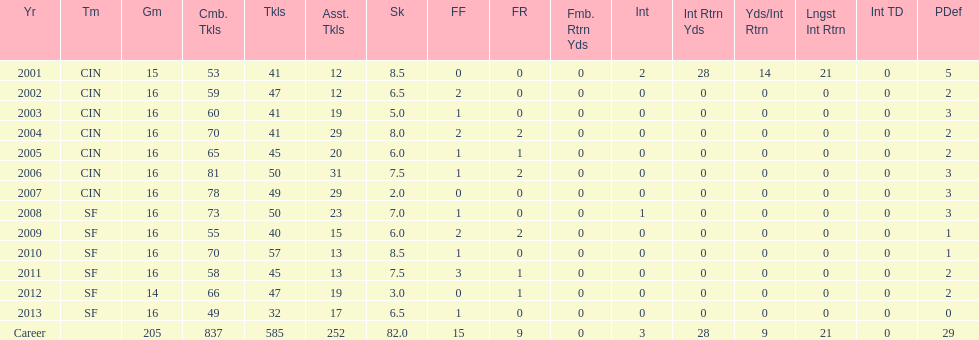How many years did he play in less than 16 games? 2. 